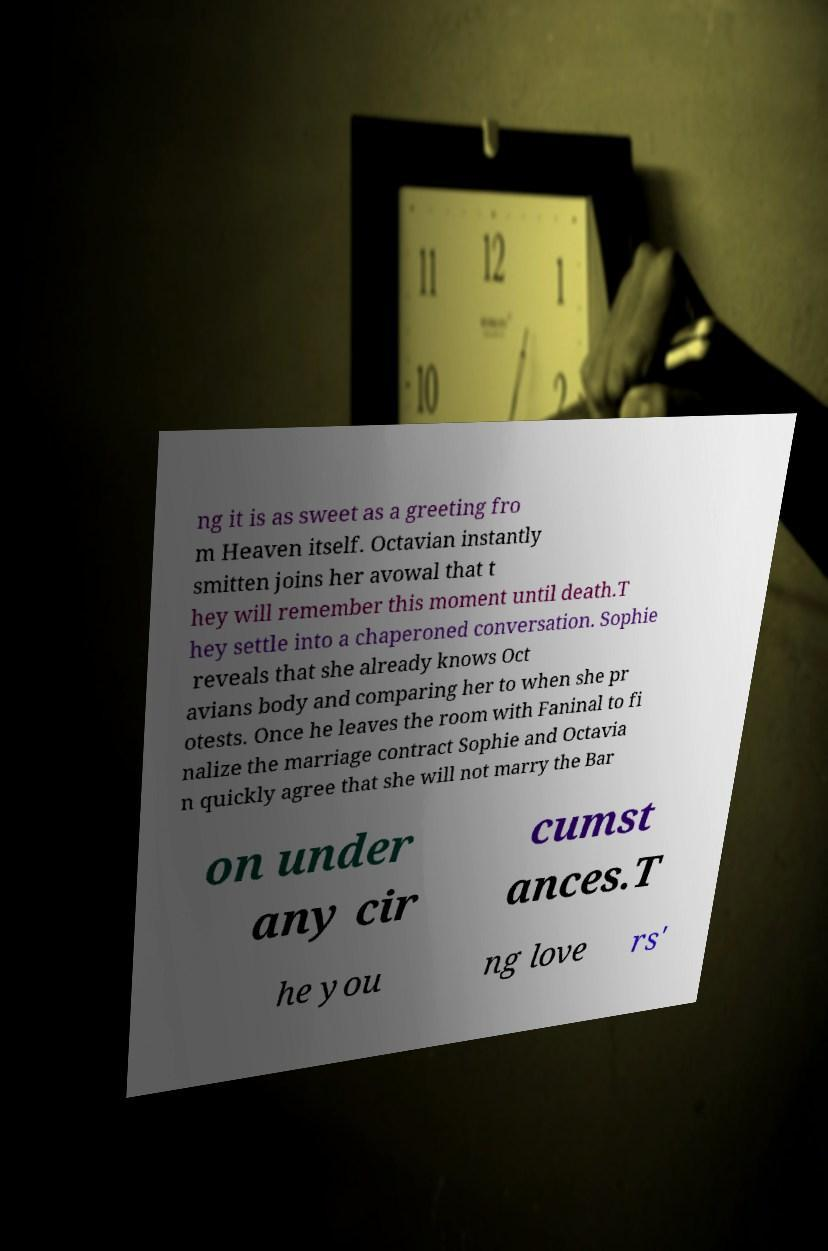Please read and relay the text visible in this image. What does it say? ng it is as sweet as a greeting fro m Heaven itself. Octavian instantly smitten joins her avowal that t hey will remember this moment until death.T hey settle into a chaperoned conversation. Sophie reveals that she already knows Oct avians body and comparing her to when she pr otests. Once he leaves the room with Faninal to fi nalize the marriage contract Sophie and Octavia n quickly agree that she will not marry the Bar on under any cir cumst ances.T he you ng love rs' 